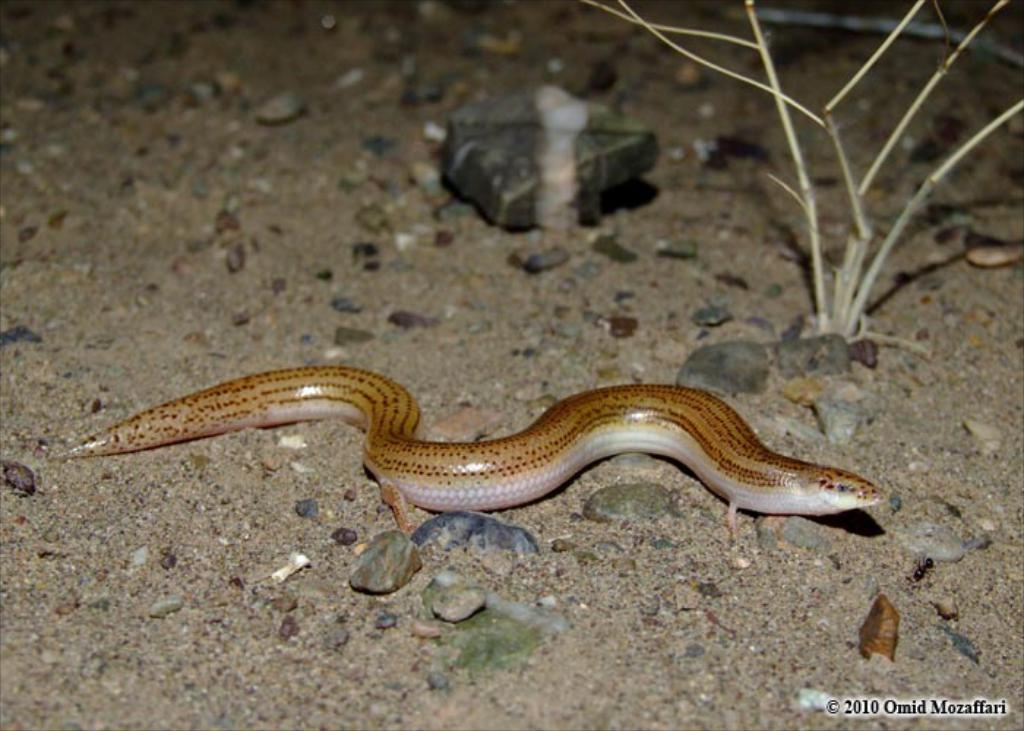What animal is present in the image? There is a snake in the image. What type of surface is the snake on? The snake is on a sand surface. What can be seen in the background of the image? There is a plant in the background of the image. Where is the text located in the image? The text is in the bottom right corner of the image. How many dinosaurs are visible in the image? There are no dinosaurs present in the image; it features a snake on a sand surface. What type of field is the snake playing in the image? There is no field or play depicted in the image; the snake is simply on a sand surface. 